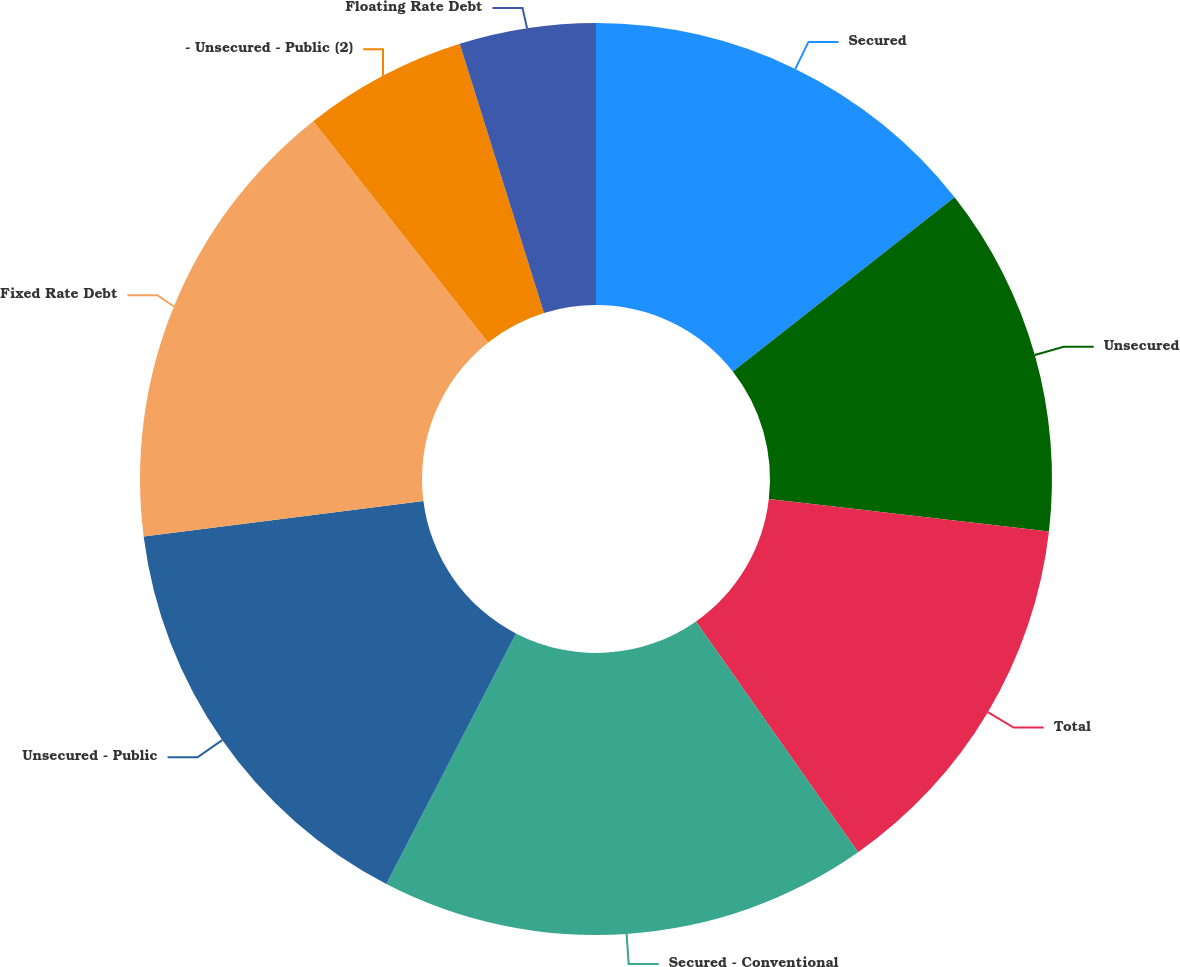Convert chart. <chart><loc_0><loc_0><loc_500><loc_500><pie_chart><fcel>Secured<fcel>Unsecured<fcel>Total<fcel>Secured - Conventional<fcel>Unsecured - Public<fcel>Fixed Rate Debt<fcel>- Unsecured - Public (2)<fcel>Floating Rate Debt<nl><fcel>14.4%<fcel>12.43%<fcel>13.42%<fcel>17.35%<fcel>15.38%<fcel>16.37%<fcel>5.81%<fcel>4.83%<nl></chart> 